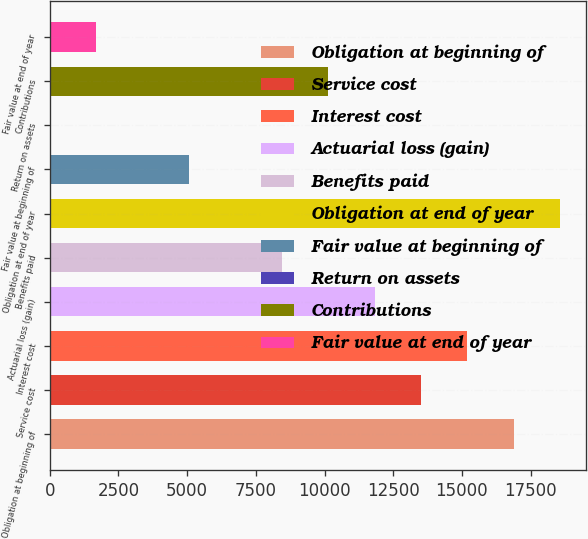<chart> <loc_0><loc_0><loc_500><loc_500><bar_chart><fcel>Obligation at beginning of<fcel>Service cost<fcel>Interest cost<fcel>Actuarial loss (gain)<fcel>Benefits paid<fcel>Obligation at end of year<fcel>Fair value at beginning of<fcel>Return on assets<fcel>Contributions<fcel>Fair value at end of year<nl><fcel>16889<fcel>13511.4<fcel>15200.2<fcel>11822.6<fcel>8445.11<fcel>18577.7<fcel>5067.57<fcel>1.26<fcel>10133.9<fcel>1690.03<nl></chart> 